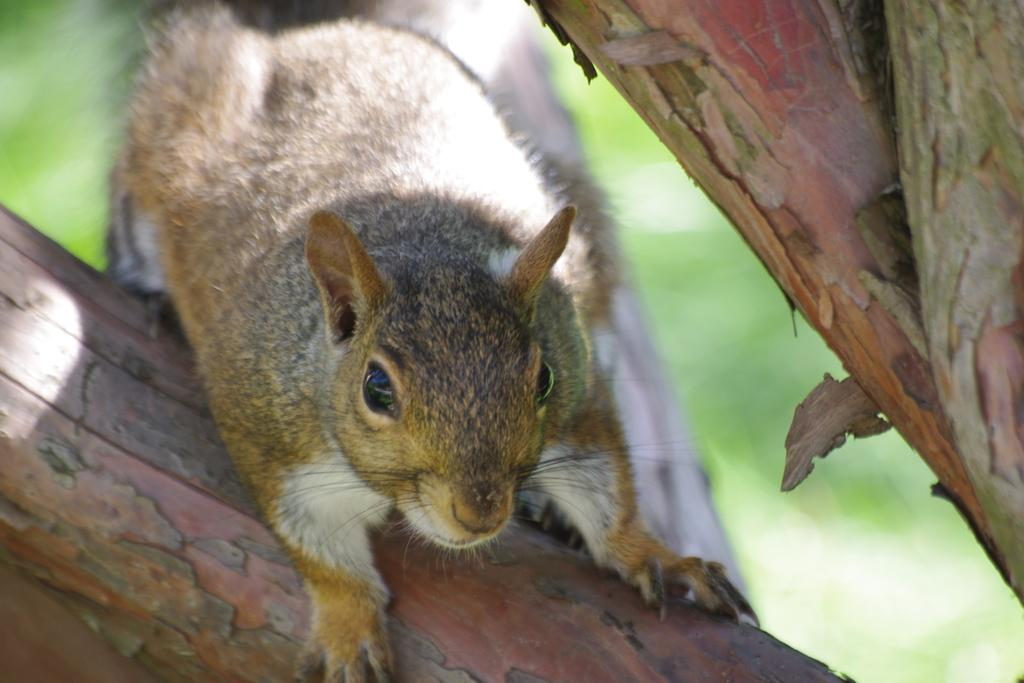What animal is present in the image? There is a squirrel in the image. Where is the squirrel located? The squirrel is on the branch of a tree. What type of drink is the squirrel holding in the image? There is no drink present in the image; the squirrel is on the branch of a tree. 